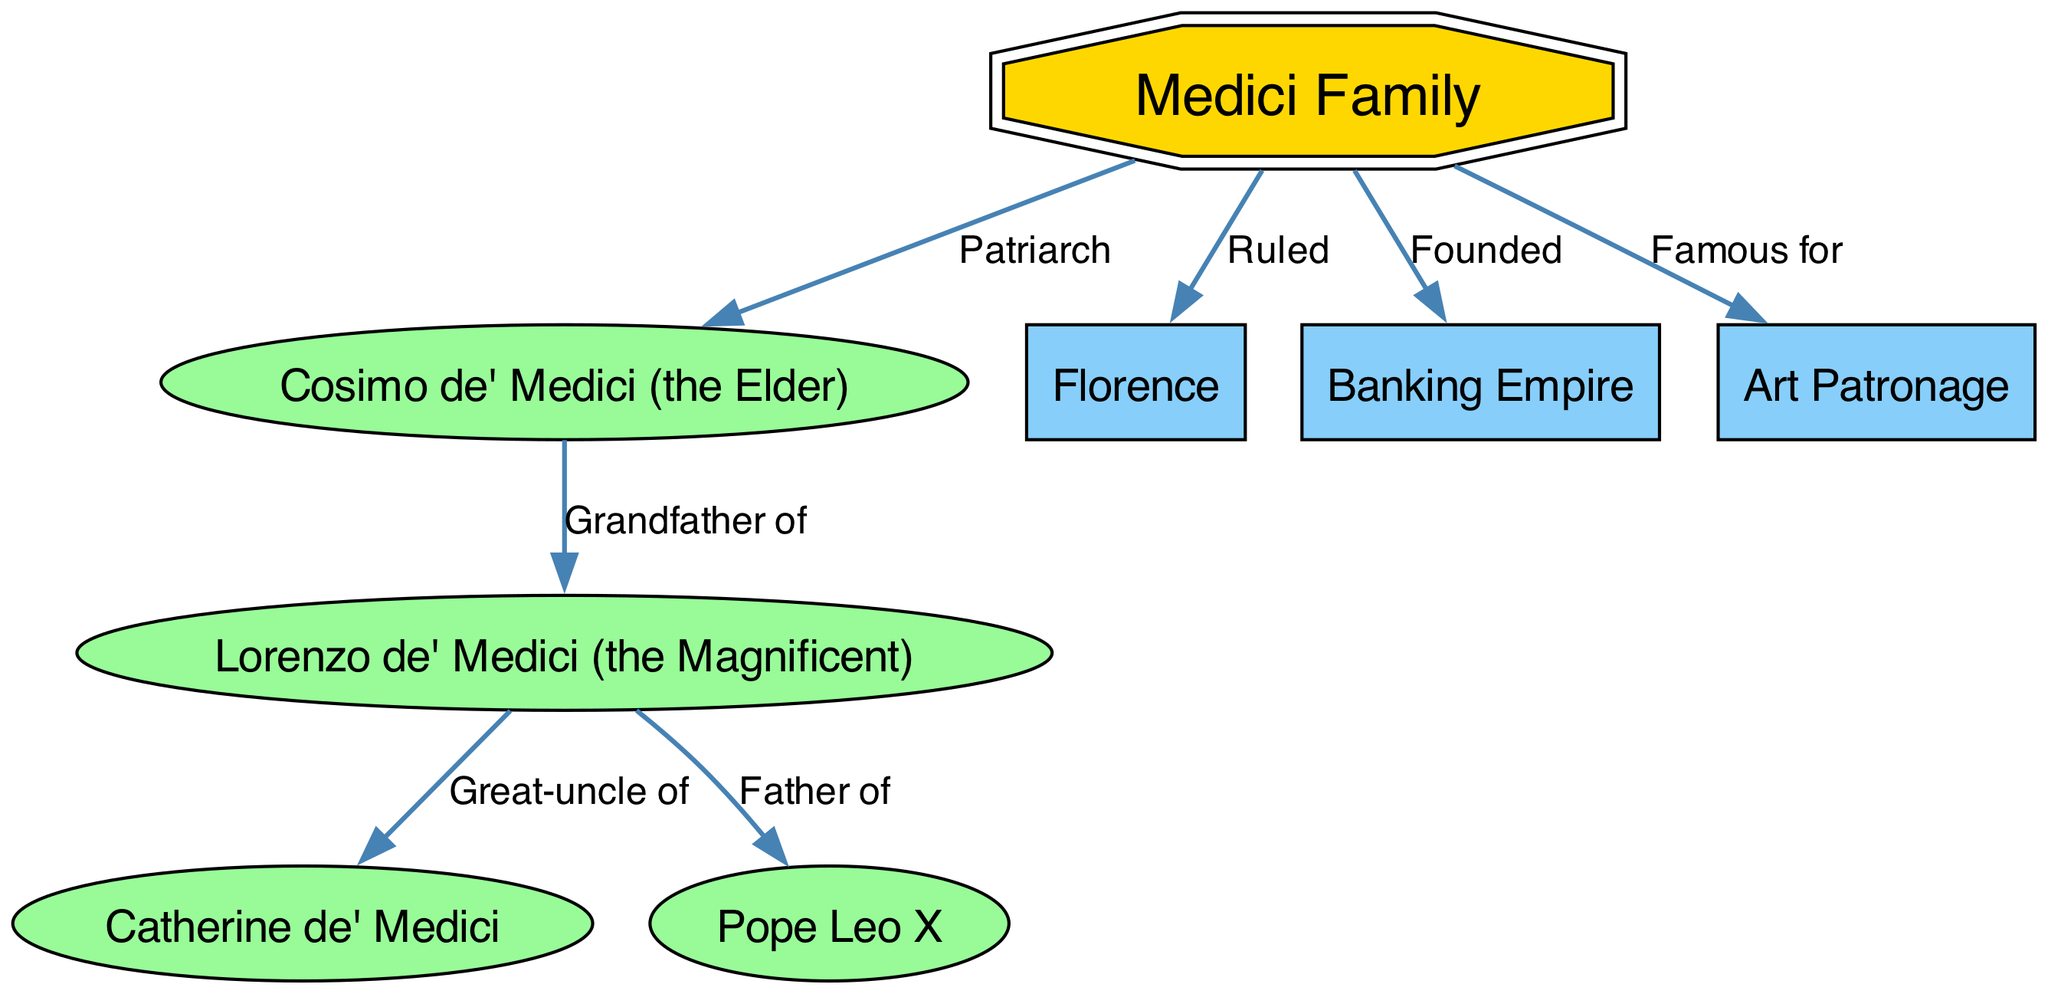What is the primary label of the central node? The central node is labeled "Medici Family," as indicated by its designation in the diagram. This node serves as the foundation for all other relationships illustrated.
Answer: Medici Family Who is identified as the patriarch of the Medici family? The diagram points to "Cosimo de' Medici (the Elder)" as the patriarch, indicating his foundational role in establishing the family's prominence.
Answer: Cosimo de' Medici (the Elder) How many nodes are there in the diagram? By counting the nodes listed, including the central node and its relationships, a total of eight distinct nodes are identified in the diagram.
Answer: 8 What is the relationship between Lorenzo de' Medici and Pope Leo X? The diagram specifies that Lorenzo de' Medici is the "Father of" Pope Leo X, indicating a direct parental connection.
Answer: Father of What is a major contribution of the Medici family as shown in the diagram? The diagram states that the Medici family is "Famous for" their "Art Patronage," revealing their significant role in supporting artists during the Renaissance.
Answer: Art Patronage What role did the Medici family have in Florence? According to the diagram, the Medici family is labeled as having "Ruled" Florence, showcasing their political power and influence in the city.
Answer: Ruled What does the relationship between Lorenzo de' Medici and Catherine de' Medici illustrate? The diagram indicates that Lorenzo is the "Great-uncle of" Catherine, showcasing familial connections across generations within the Medici lineage.
Answer: Great-uncle of How did the Medici family contribute to the economy of their time? The concept map highlights that the Medici family "Founded" a "Banking Empire," illustrating their substantial role in the financial sector of the Renaissance.
Answer: Founded Which node signifies one of the family's key areas of influence outside of politics? Within the diagram, "Art Patronage" is indicated as a key area of influence for the Medici, signaling their impact in arts and culture.
Answer: Art Patronage 